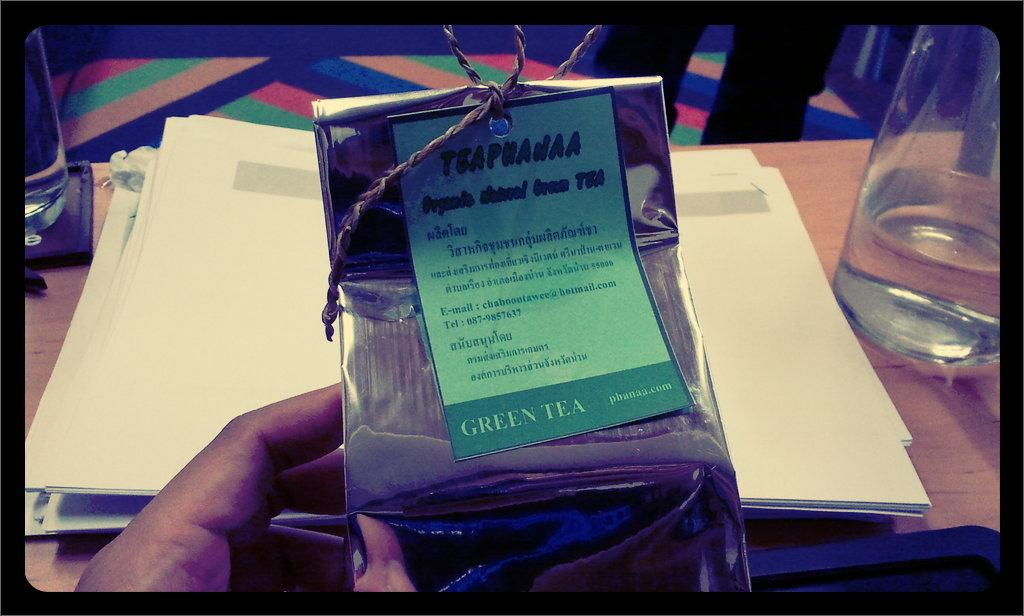<image>
Provide a brief description of the given image. A person is holding a package with a label that says Green Tea. 